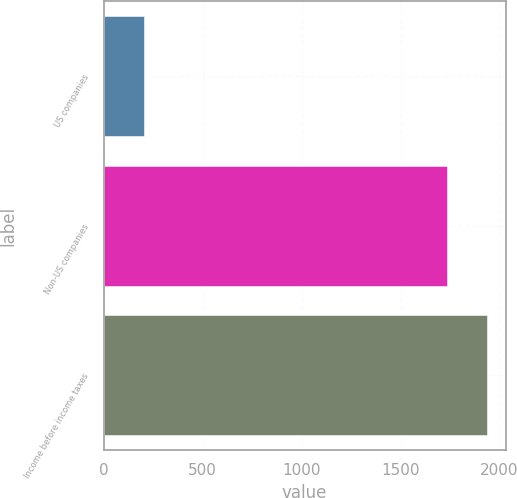Convert chart to OTSL. <chart><loc_0><loc_0><loc_500><loc_500><bar_chart><fcel>US companies<fcel>Non-US companies<fcel>Income before income taxes<nl><fcel>202<fcel>1732<fcel>1934<nl></chart> 